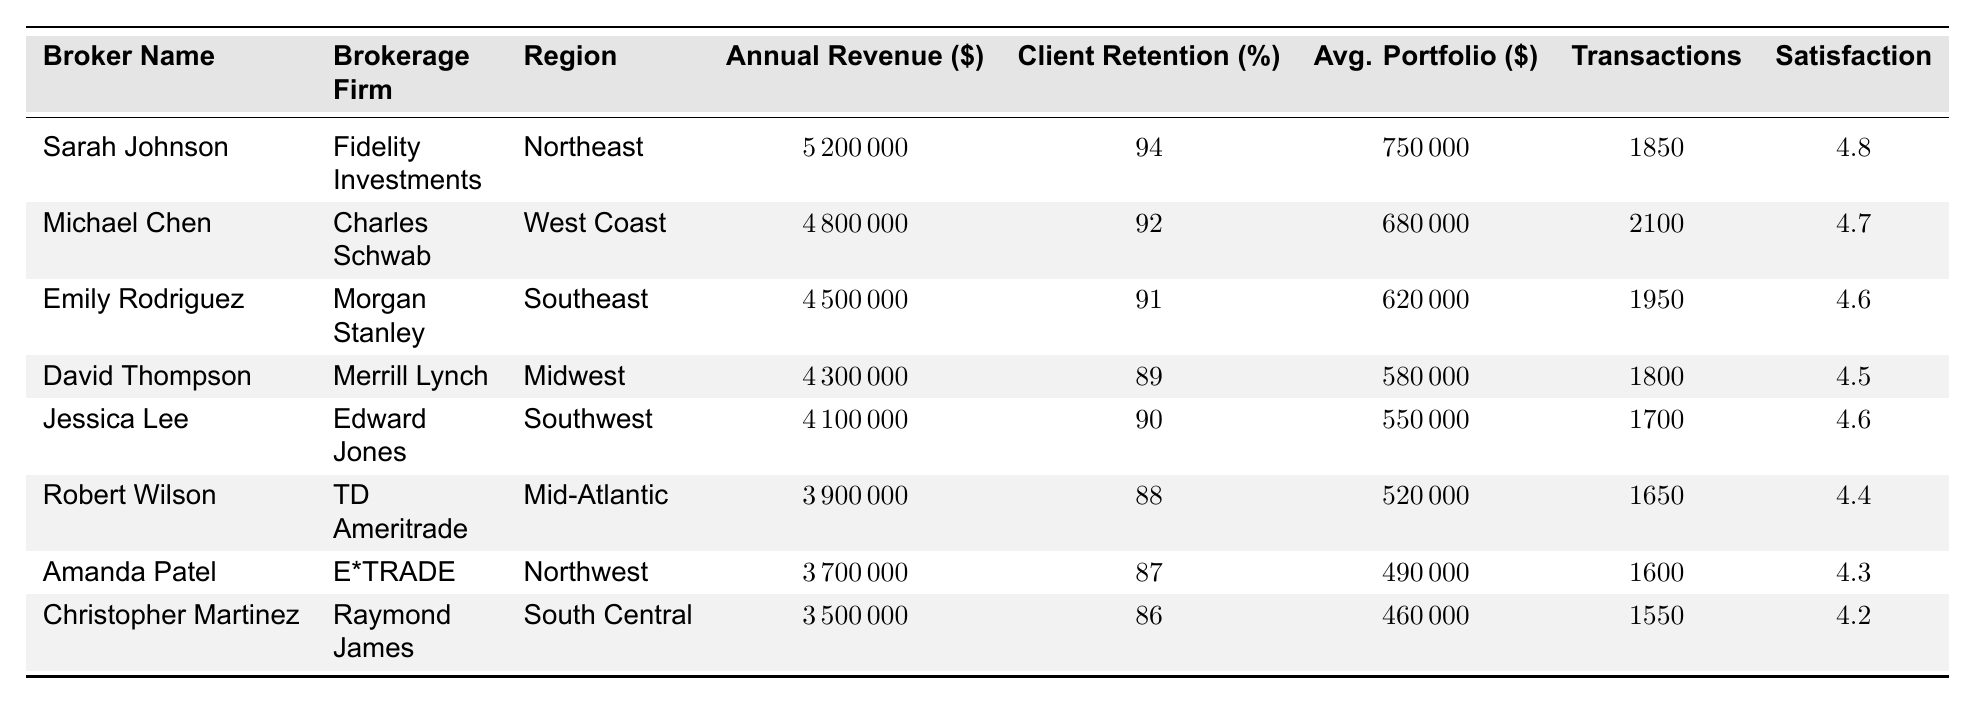What is the annual revenue of Sarah Johnson? According to the table, Sarah Johnson's annual revenue is listed directly under her name in the Annual Revenue column, which shows \$5,200,000.
Answer: 5200000 Which broker has the highest client retention rate? From the Client Retention (%) column, we can see each broker's retention rate. Sarah Johnson has the highest rate at 94%.
Answer: Sarah Johnson What is the average client portfolio value among all brokers? To calculate the average, we add the average client portfolio values: (750000 + 680000 + 620000 + 580000 + 550000 + 520000 + 490000 + 460000) = 3850000. Then we divide by the number of brokers (8), giving us 3850000 / 8 = 481250.
Answer: 481250 Is Jessica Lee's customer satisfaction score higher than David Thompson's? We compare the scores from the Customer Satisfaction column. Jessica Lee has a score of 4.6 and David Thompson has a score of 4.5. Since 4.6 is greater than 4.5, the statement is true.
Answer: Yes What is the total annual revenue generated by brokers from the Northeast and West Coast regions combined? We look at the annual revenue for both regions: Sarah Johnson (Northeast) has \$5,200,000 and Michael Chen (West Coast) has \$4,800,000. Adding these: 5200000 + 4800000 = 10000000.
Answer: 10000000 Which region has brokers with the lowest average portfolio value? To find the region with the lowest average portfolio value, we identify the lowest values in the Avg. Portfolio (\$) column. Christopher Martinez from South Central has \$460,000, which is the minimum.
Answer: South Central What is the difference in customer satisfaction scores between the highest and lowest scoring brokers? We identify the highest score belonging to Sarah Johnson (4.8) and the lowest score belonging to Christopher Martinez (4.2). The difference is calculated as 4.8 - 4.2 = 0.6.
Answer: 0.6 How many transactions did Michael Chen complete compared to Jessica Lee? Checking the Transactions column, Michael Chen completed 2,100 transactions while Jessica Lee completed 1,700 transactions. The difference is 2100 - 1700 = 400.
Answer: 400 Which brokerage firm has the broker with the highest annual revenue? The highest annual revenue is \$5,200,000, which belongs to Sarah Johnson who is from Fidelity Investments. Therefore, Fidelity Investments is the brokerage firm with the highest annual revenue.
Answer: Fidelity Investments Are there any brokers with a customer satisfaction score below 4.5? We can check the Customer Satisfaction column. The brokers Robert Wilson (4.4), Amanda Patel (4.3), and Christopher Martinez (4.2) all have scores below 4.5, which confirms this is true.
Answer: Yes 